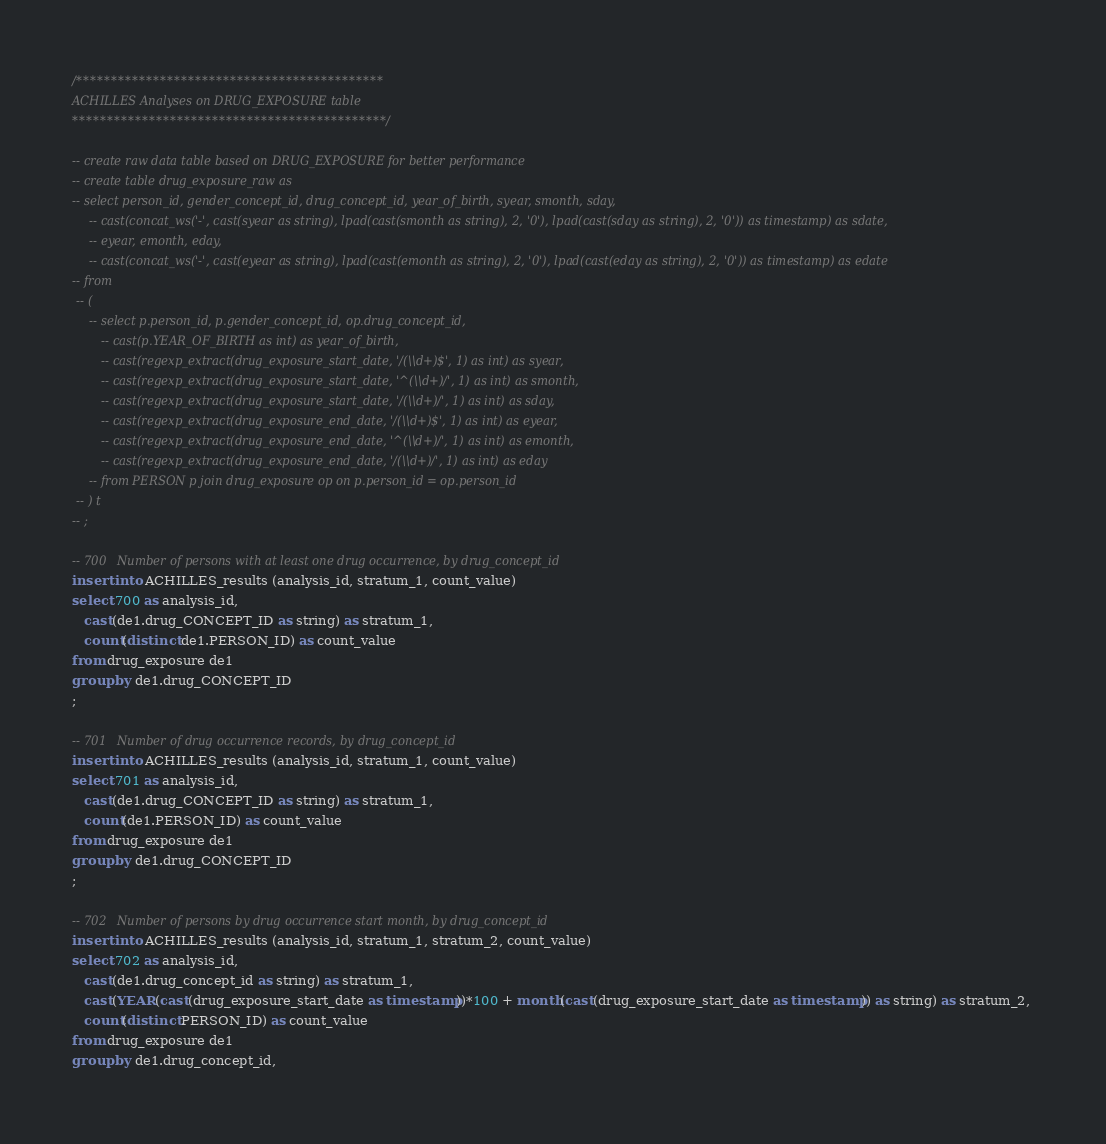Convert code to text. <code><loc_0><loc_0><loc_500><loc_500><_SQL_>
/********************************************
ACHILLES Analyses on DRUG_EXPOSURE table
*********************************************/

-- create raw data table based on DRUG_EXPOSURE for better performance
-- create table drug_exposure_raw as
-- select person_id, gender_concept_id, drug_concept_id, year_of_birth, syear, smonth, sday, 
	-- cast(concat_ws('-', cast(syear as string), lpad(cast(smonth as string), 2, '0'), lpad(cast(sday as string), 2, '0')) as timestamp) as sdate,
	-- eyear, emonth, eday, 
	-- cast(concat_ws('-', cast(eyear as string), lpad(cast(emonth as string), 2, '0'), lpad(cast(eday as string), 2, '0')) as timestamp) as edate
-- from 
 -- (
	-- select p.person_id, p.gender_concept_id, op.drug_concept_id,
	   -- cast(p.YEAR_OF_BIRTH as int) as year_of_birth, 
	   -- cast(regexp_extract(drug_exposure_start_date, '/(\\d+)$', 1) as int) as syear,
	   -- cast(regexp_extract(drug_exposure_start_date, '^(\\d+)/', 1) as int) as smonth,
	   -- cast(regexp_extract(drug_exposure_start_date, '/(\\d+)/', 1) as int) as sday,
	   -- cast(regexp_extract(drug_exposure_end_date, '/(\\d+)$', 1) as int) as eyear,
	   -- cast(regexp_extract(drug_exposure_end_date, '^(\\d+)/', 1) as int) as emonth,
	   -- cast(regexp_extract(drug_exposure_end_date, '/(\\d+)/', 1) as int) as eday
	-- from PERSON p join drug_exposure op on p.person_id = op.person_id
 -- ) t
-- ;

-- 700   Number of persons with at least one drug occurrence, by drug_concept_id
insert into ACHILLES_results (analysis_id, stratum_1, count_value)
select 700 as analysis_id, 
   cast(de1.drug_CONCEPT_ID as string) as stratum_1,
   count(distinct de1.PERSON_ID) as count_value
from drug_exposure de1
group by de1.drug_CONCEPT_ID
;

-- 701   Number of drug occurrence records, by drug_concept_id
insert into ACHILLES_results (analysis_id, stratum_1, count_value)
select 701 as analysis_id, 
   cast(de1.drug_CONCEPT_ID as string) as stratum_1,
   count(de1.PERSON_ID) as count_value
from drug_exposure de1
group by de1.drug_CONCEPT_ID
;

-- 702   Number of persons by drug occurrence start month, by drug_concept_id
insert into ACHILLES_results (analysis_id, stratum_1, stratum_2, count_value)
select 702 as analysis_id,   
   cast(de1.drug_concept_id as string) as stratum_1,
   cast(YEAR(cast(drug_exposure_start_date as timestamp))*100 + month(cast(drug_exposure_start_date as timestamp)) as string) as stratum_2, 
   count(distinct PERSON_ID) as count_value
from drug_exposure de1
group by de1.drug_concept_id, </code> 